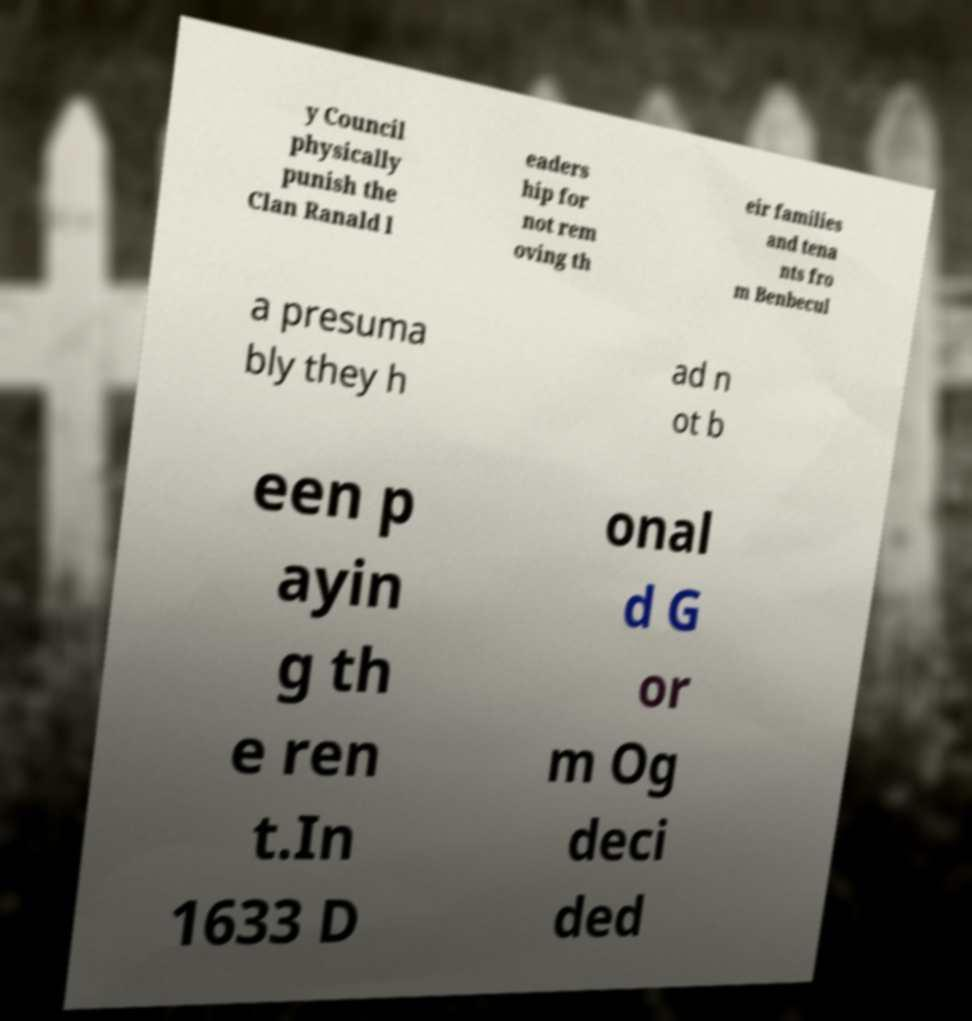What messages or text are displayed in this image? I need them in a readable, typed format. y Council physically punish the Clan Ranald l eaders hip for not rem oving th eir families and tena nts fro m Benbecul a presuma bly they h ad n ot b een p ayin g th e ren t.In 1633 D onal d G or m Og deci ded 